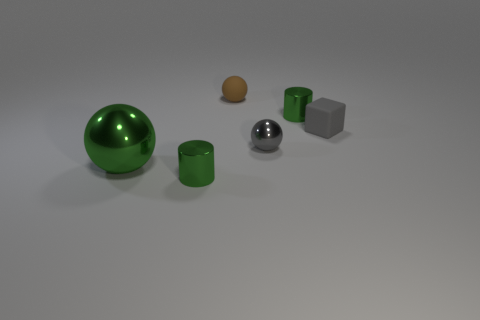Subtract 1 spheres. How many spheres are left? 2 Add 1 small green rubber cylinders. How many objects exist? 7 Subtract 0 brown cubes. How many objects are left? 6 Subtract all blocks. How many objects are left? 5 Subtract all green things. Subtract all rubber objects. How many objects are left? 1 Add 3 brown objects. How many brown objects are left? 4 Add 5 gray matte objects. How many gray matte objects exist? 6 